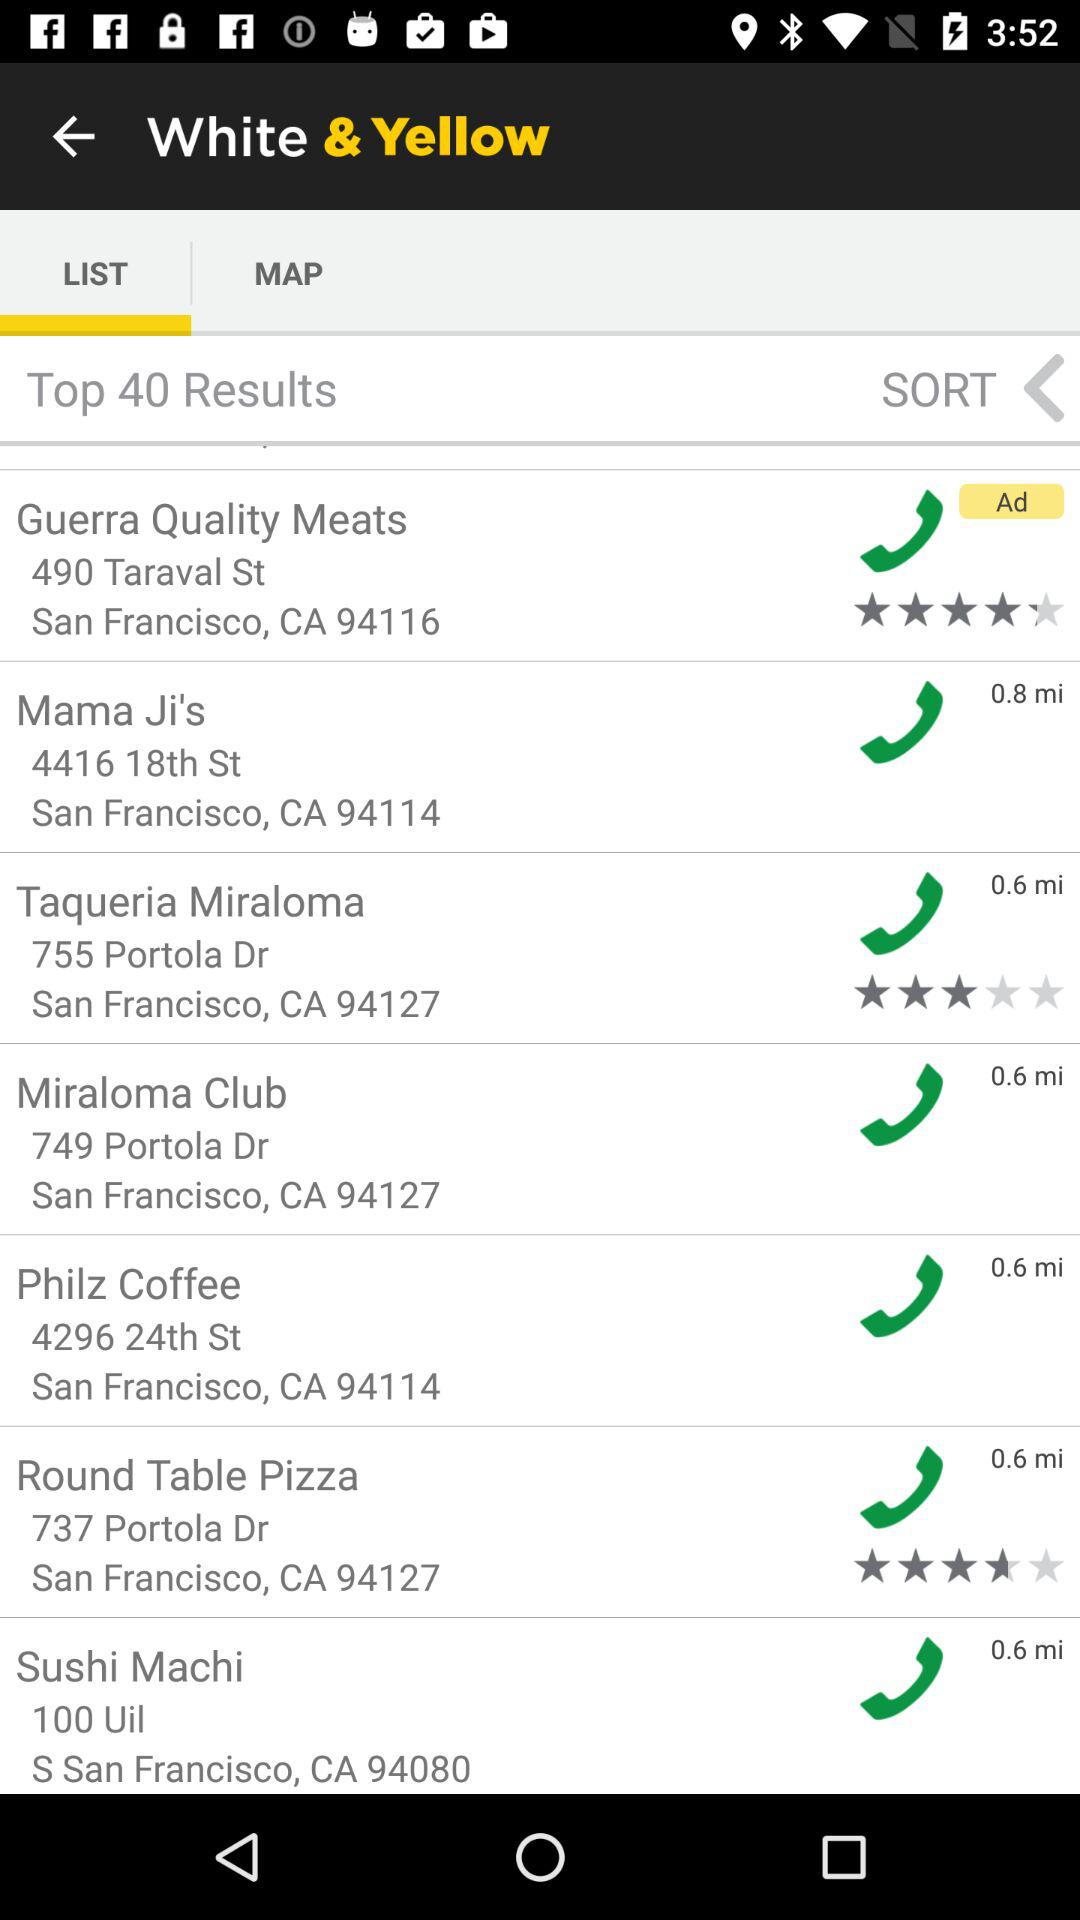What is the rating for "Taqueria Miraloma"? The rating is 3 stars. 